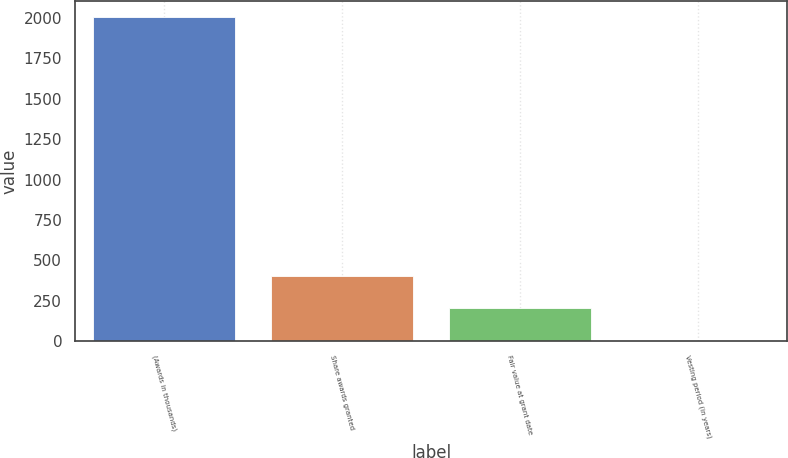Convert chart. <chart><loc_0><loc_0><loc_500><loc_500><bar_chart><fcel>(Awards in thousands)<fcel>Share awards granted<fcel>Fair value at grant date<fcel>Vesting period (in years)<nl><fcel>2006<fcel>403.6<fcel>203.3<fcel>3<nl></chart> 